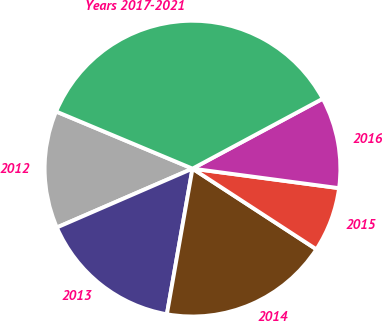<chart> <loc_0><loc_0><loc_500><loc_500><pie_chart><fcel>2012<fcel>2013<fcel>2014<fcel>2015<fcel>2016<fcel>Years 2017-2021<nl><fcel>12.83%<fcel>15.71%<fcel>18.58%<fcel>7.08%<fcel>9.95%<fcel>35.84%<nl></chart> 